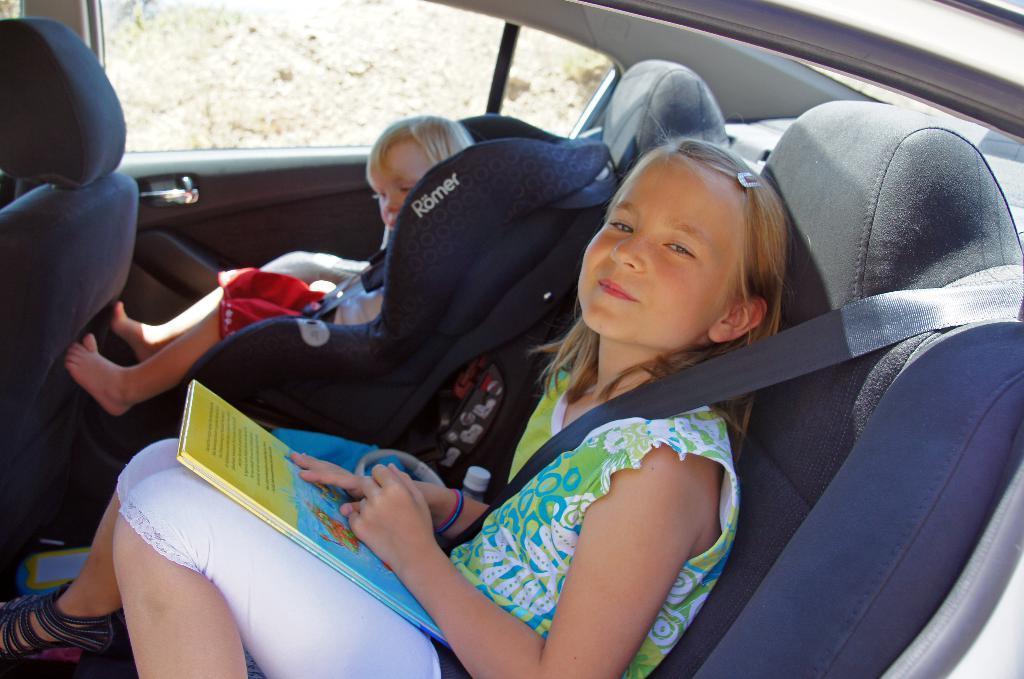Can you describe this image briefly? They are both sitting on a car. In front side we have a girl. She is wearing a seatbelt. She is smiling. 